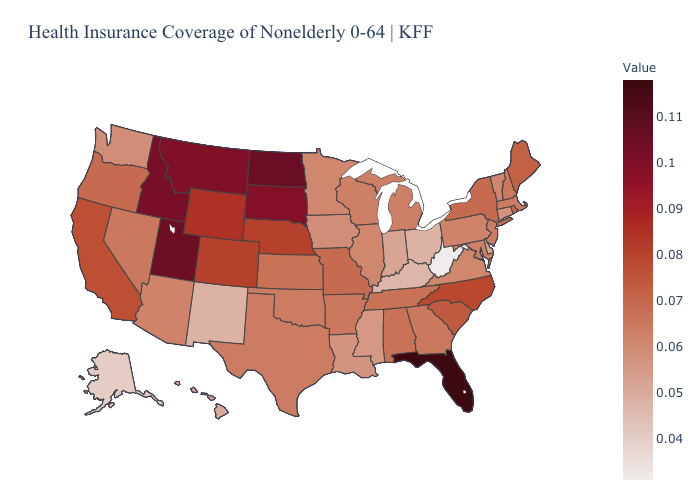Among the states that border Indiana , which have the highest value?
Keep it brief. Michigan. Which states have the lowest value in the USA?
Quick response, please. West Virginia. Among the states that border Rhode Island , does Connecticut have the lowest value?
Write a very short answer. Yes. Which states have the lowest value in the West?
Short answer required. Alaska. Does Maryland have a lower value than Hawaii?
Keep it brief. No. Does Hawaii have the lowest value in the West?
Write a very short answer. No. Does Missouri have a lower value than Connecticut?
Quick response, please. No. Among the states that border New Mexico , does Utah have the highest value?
Short answer required. Yes. 